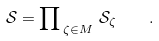<formula> <loc_0><loc_0><loc_500><loc_500>\mathcal { S } = \prod \nolimits _ { \, \zeta \in M } \, \mathcal { S } _ { \zeta } \quad .</formula> 